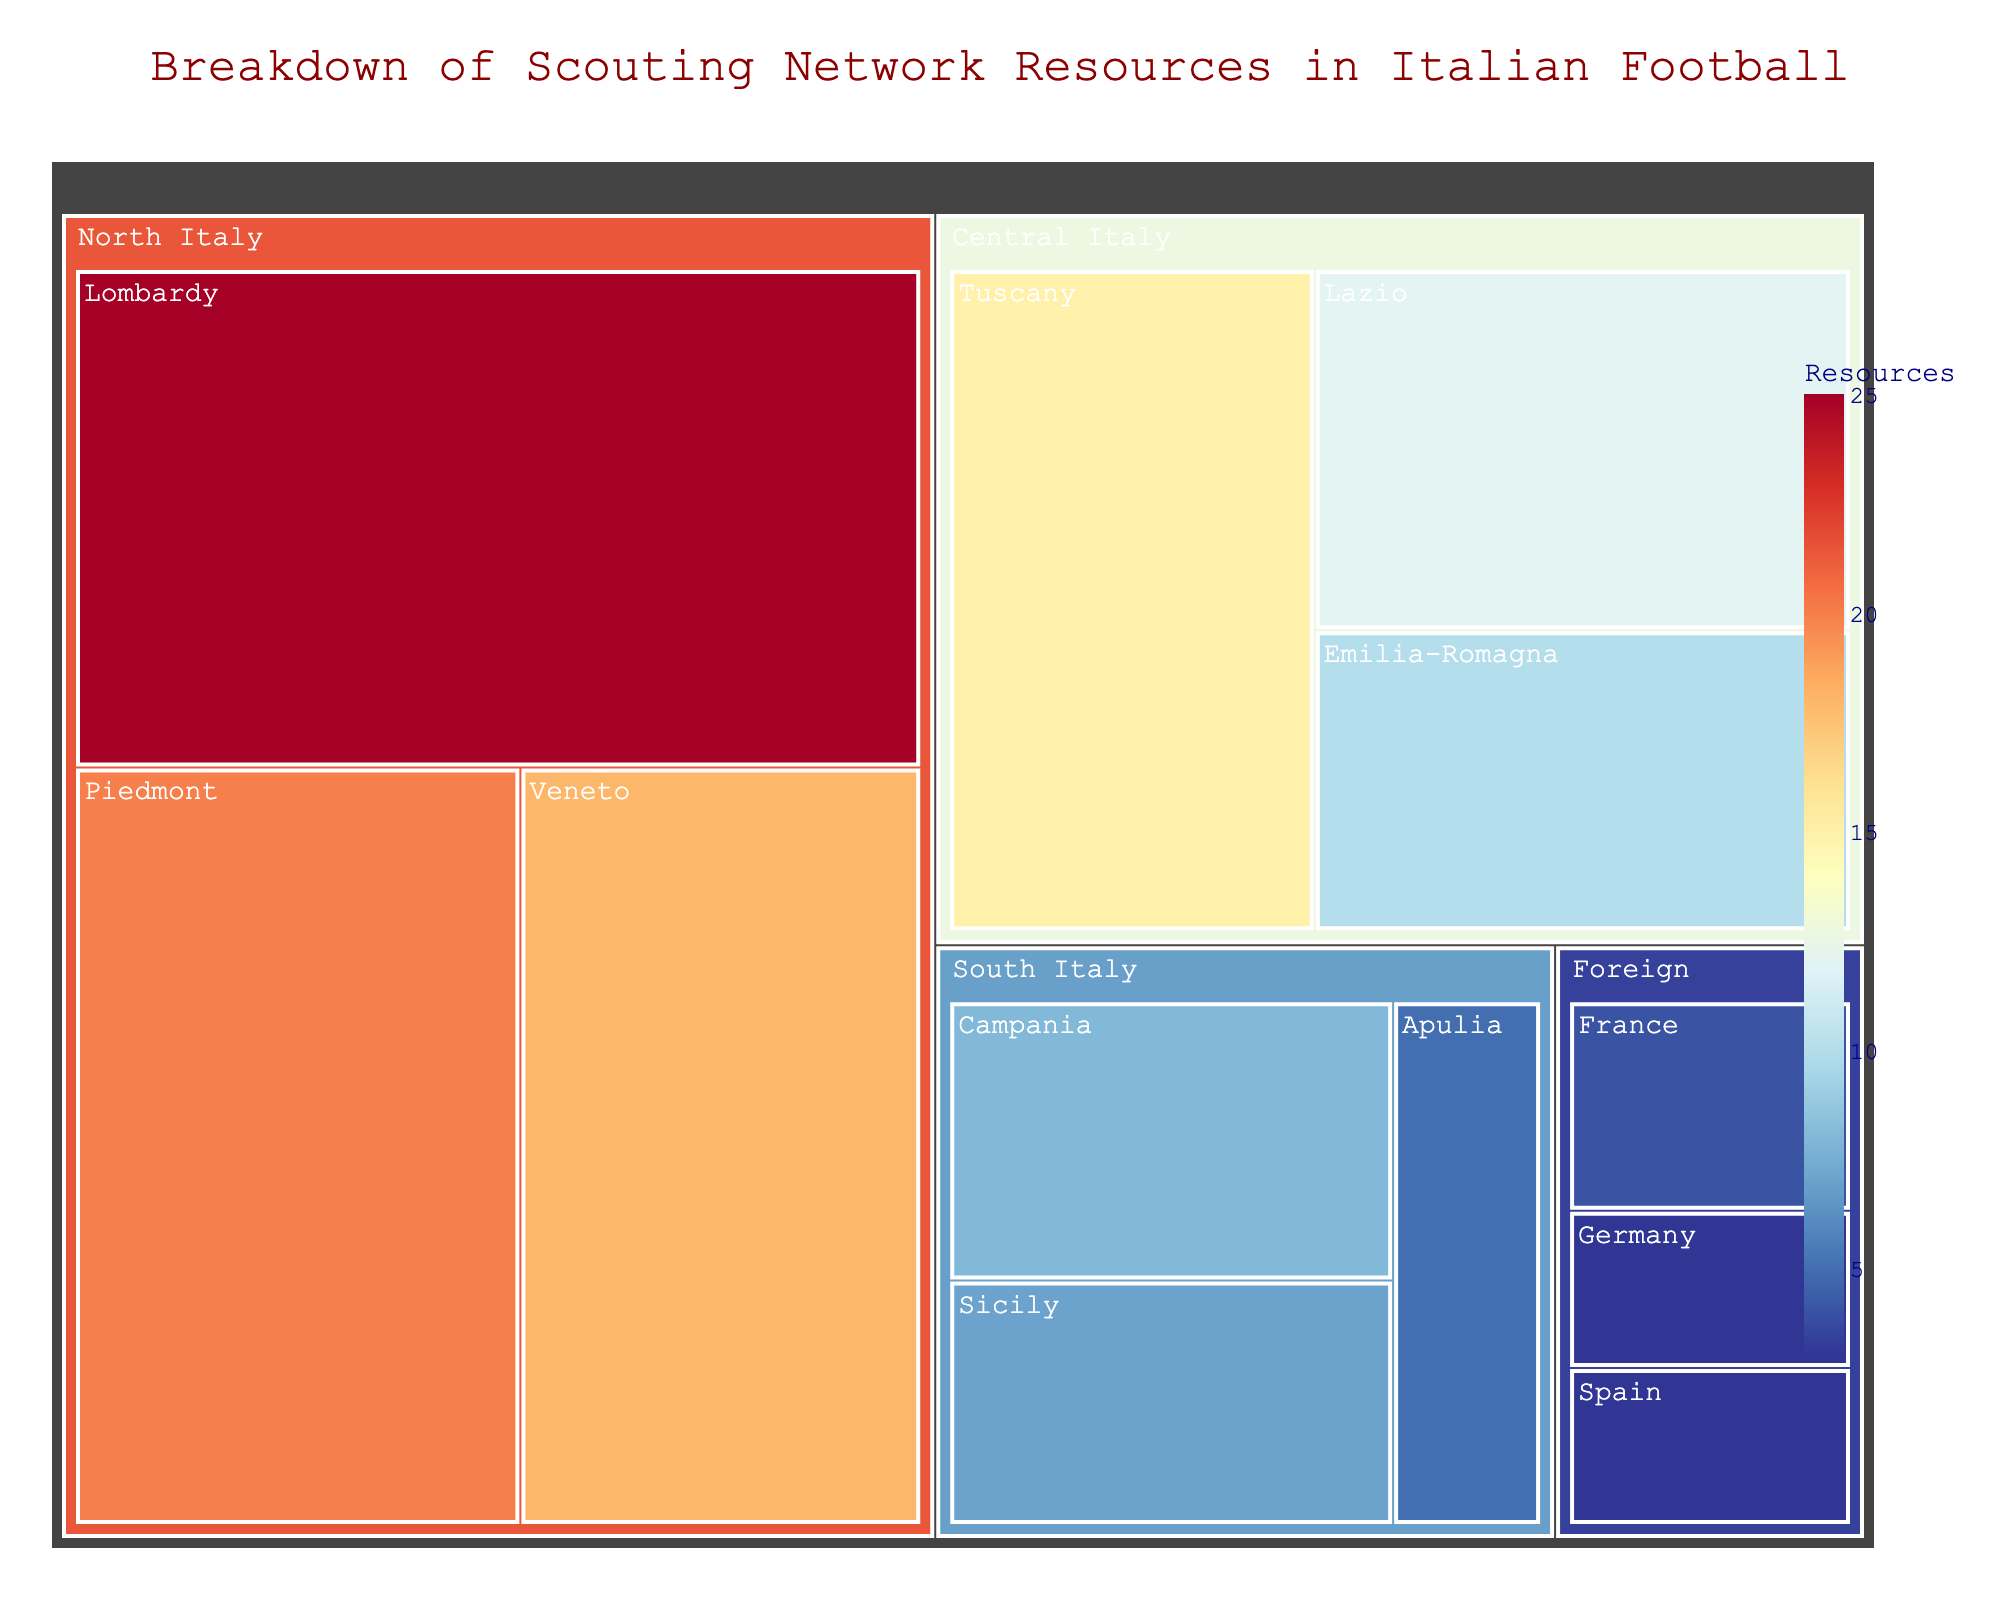What is the title of the figure? The title is displayed at the top and centered in dark red font. It describes what the figure is about.
Answer: Breakdown of Scouting Network Resources in Italian Football Which region has the highest allocated resources? The largest block in the Treemap represents the region with the highest resources.
Answer: North Italy How many resources are allocated to Foreign regions? Look for the 'Foreign' category in the Treemap and sum the values of all subregions under it.
Answer: 10 Compare the resources allocated between Lombardy and Tuscany. Which one has more, and by how much? Find the blocks for Lombardy and Tuscany, and subtract the smaller value from the larger one. Lombardy has 25, and Tuscany has 15.
Answer: Lombardy by 10 What is the average number of resources allocated to subregions within Central Italy? Locate all subregions within Central Italy, sum their values, and divide by the number of subregions (3). The values are 15, 12, and 10.
Answer: 12.33 If the resources for Veneto and Piedmont were combined, what would be the total? Add the values of Veneto (18) and Piedmont (20).
Answer: 38 Is the number of resources allocated to Sicily less than the number allocated to Emilia-Romagna? Compare the blocks representing Sicily and Emilia-Romagna. Sicily has 7 resources and Emilia-Romagna has 10.
Answer: Yes Which subregion within South Italy has the least allocated resources? Look for the smallest block within the South Italy region.
Answer: Apulia By how much do the resources for Campania and Apulia together exceed those for France? Sum the resources for Campania (8) and Apulia (5) and subtract the resources for France (4).
Answer: 9 How many subregions are there in total? Count all unique subregions listed in the data.
Answer: 12 